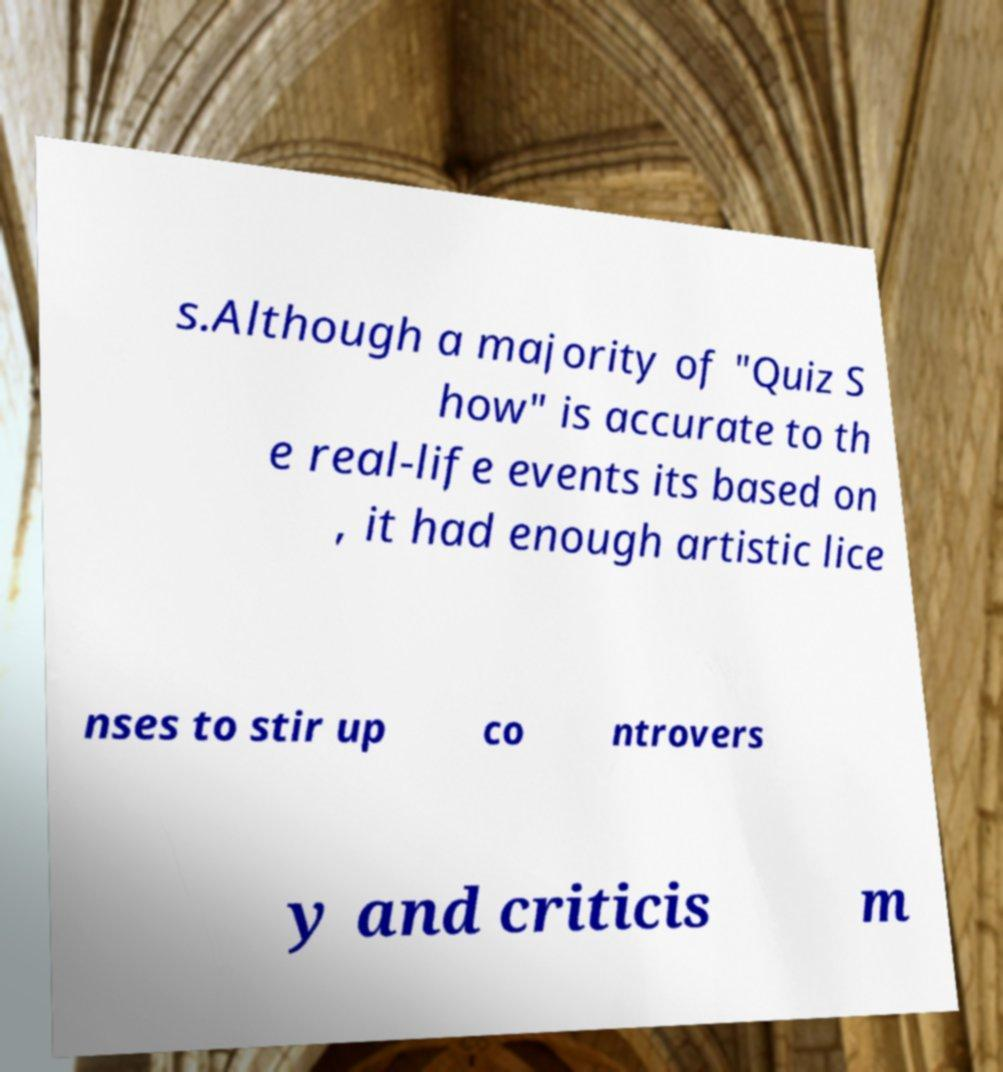There's text embedded in this image that I need extracted. Can you transcribe it verbatim? s.Although a majority of "Quiz S how" is accurate to th e real-life events its based on , it had enough artistic lice nses to stir up co ntrovers y and criticis m 